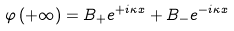<formula> <loc_0><loc_0><loc_500><loc_500>\varphi \left ( + \infty \right ) = B _ { + } e ^ { + i \kappa x } + B _ { - } e ^ { - i \kappa x }</formula> 